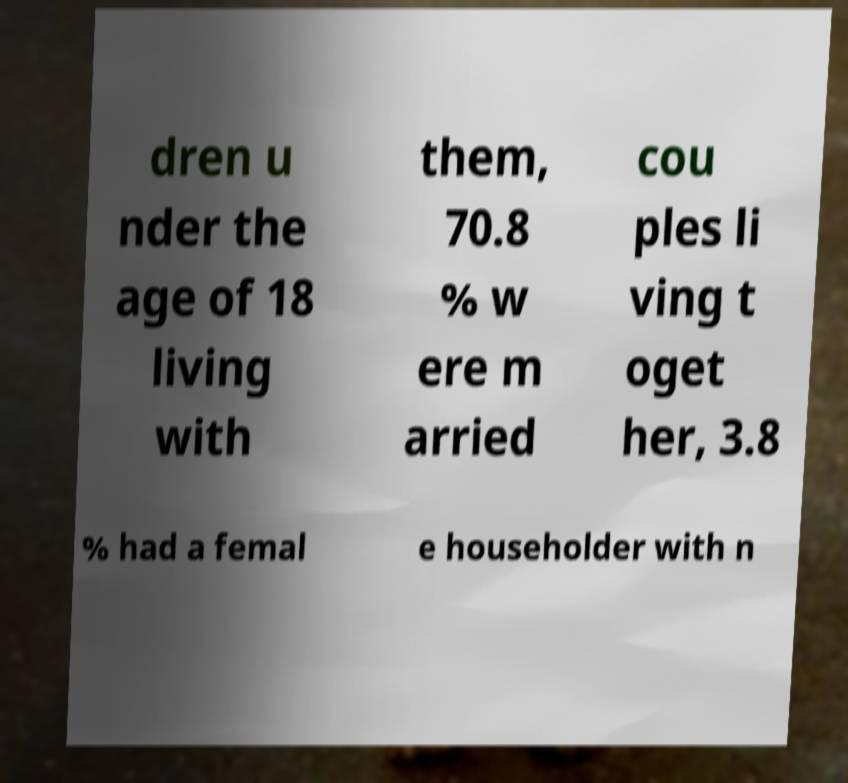For documentation purposes, I need the text within this image transcribed. Could you provide that? dren u nder the age of 18 living with them, 70.8 % w ere m arried cou ples li ving t oget her, 3.8 % had a femal e householder with n 